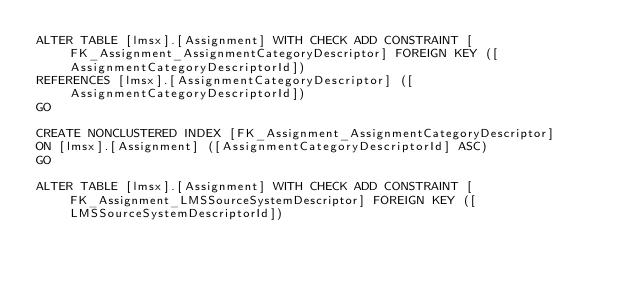<code> <loc_0><loc_0><loc_500><loc_500><_SQL_>ALTER TABLE [lmsx].[Assignment] WITH CHECK ADD CONSTRAINT [FK_Assignment_AssignmentCategoryDescriptor] FOREIGN KEY ([AssignmentCategoryDescriptorId])
REFERENCES [lmsx].[AssignmentCategoryDescriptor] ([AssignmentCategoryDescriptorId])
GO

CREATE NONCLUSTERED INDEX [FK_Assignment_AssignmentCategoryDescriptor]
ON [lmsx].[Assignment] ([AssignmentCategoryDescriptorId] ASC)
GO

ALTER TABLE [lmsx].[Assignment] WITH CHECK ADD CONSTRAINT [FK_Assignment_LMSSourceSystemDescriptor] FOREIGN KEY ([LMSSourceSystemDescriptorId])</code> 